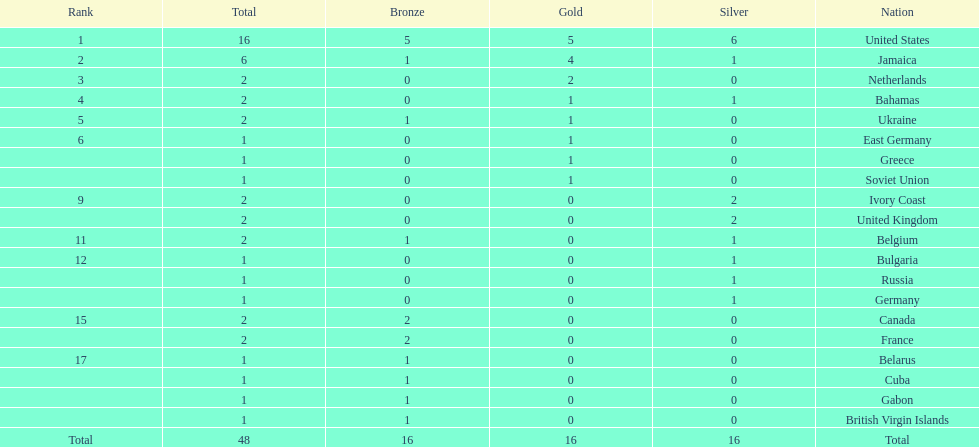What is the average number of gold medals won by the top 5 nations? 2.6. 